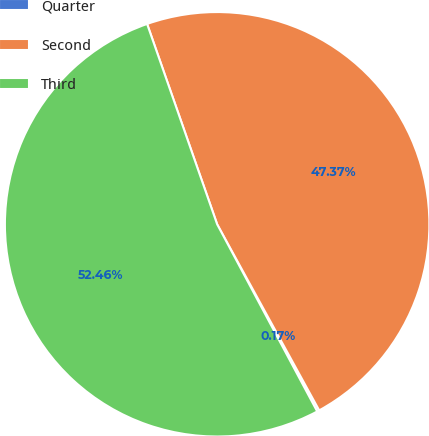<chart> <loc_0><loc_0><loc_500><loc_500><pie_chart><fcel>Quarter<fcel>Second<fcel>Third<nl><fcel>0.17%<fcel>47.37%<fcel>52.46%<nl></chart> 